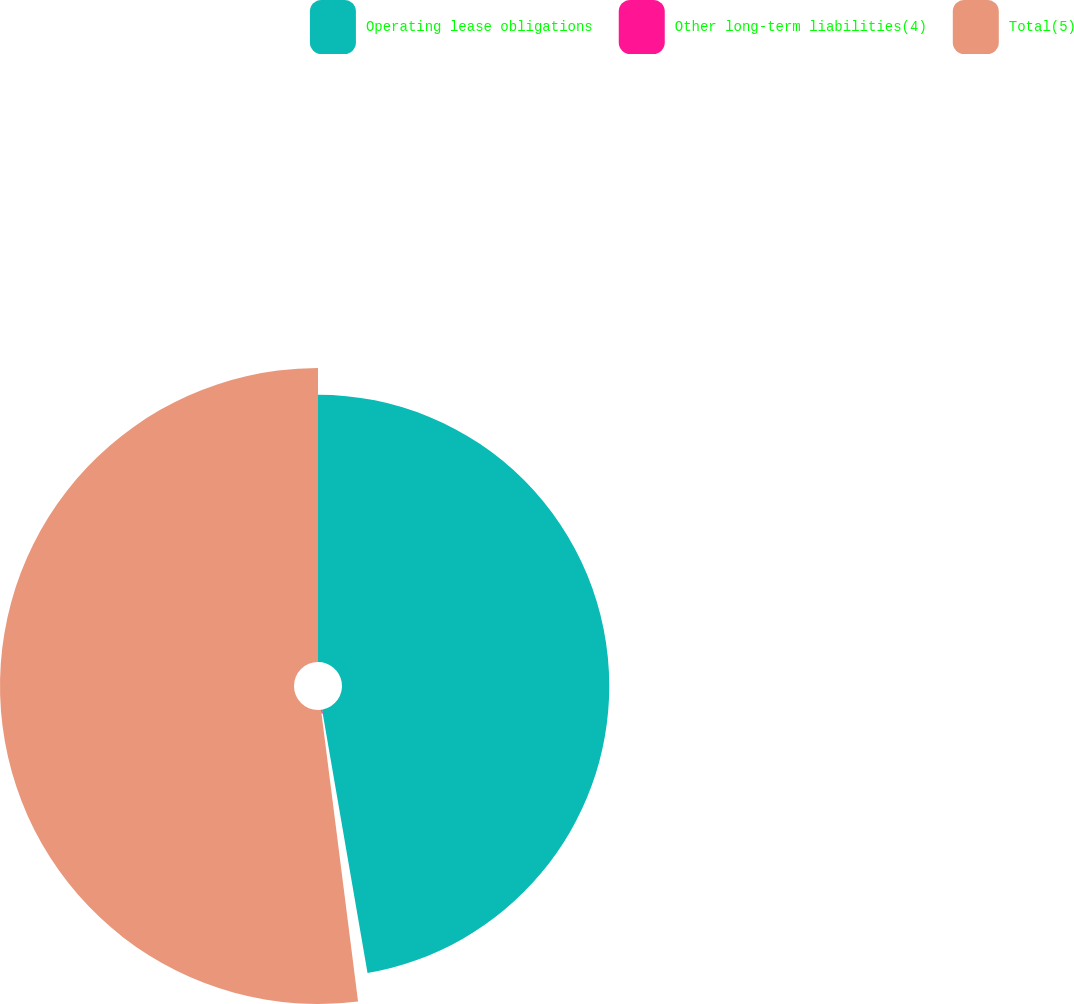Convert chart. <chart><loc_0><loc_0><loc_500><loc_500><pie_chart><fcel>Operating lease obligations<fcel>Other long-term liabilities(4)<fcel>Total(5)<nl><fcel>47.28%<fcel>0.71%<fcel>52.01%<nl></chart> 